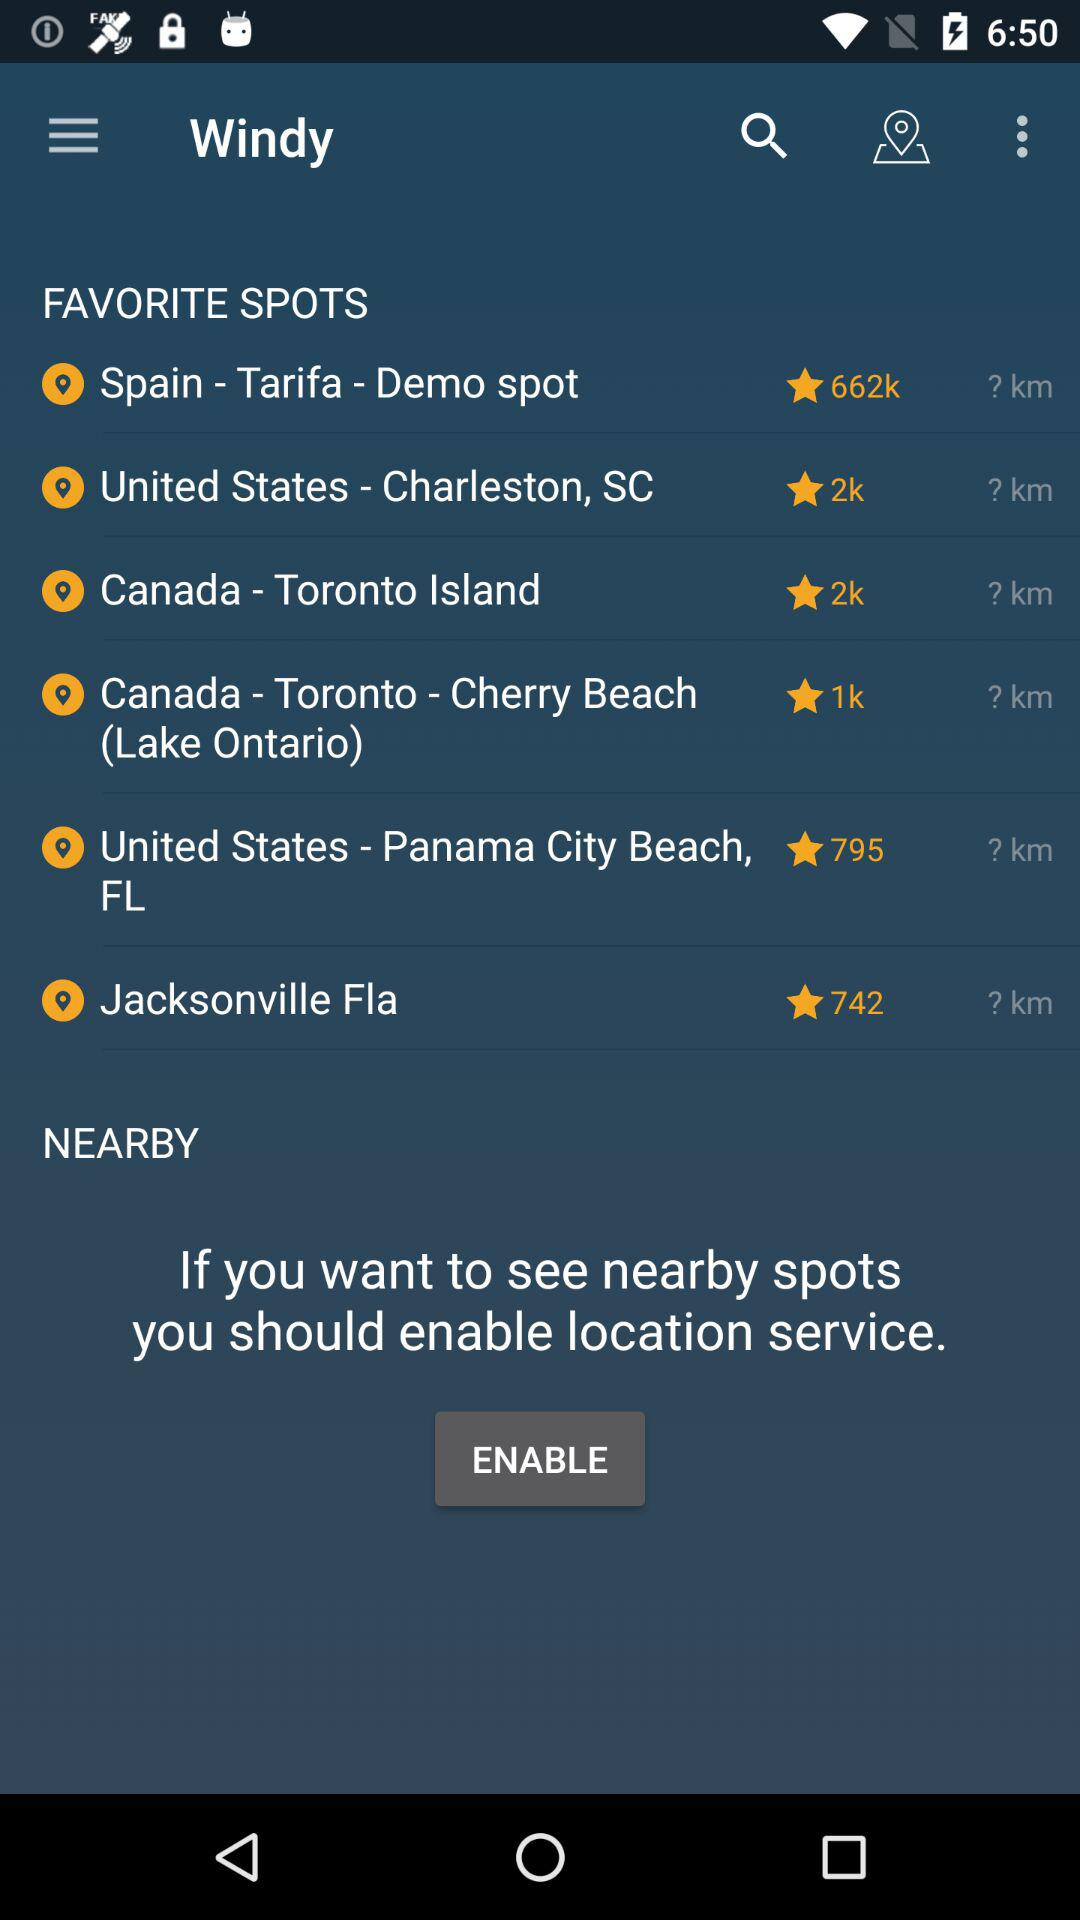What is the number of ratings for the Demo spot in Tarifa, Spain? The number of ratings is 662,000. 